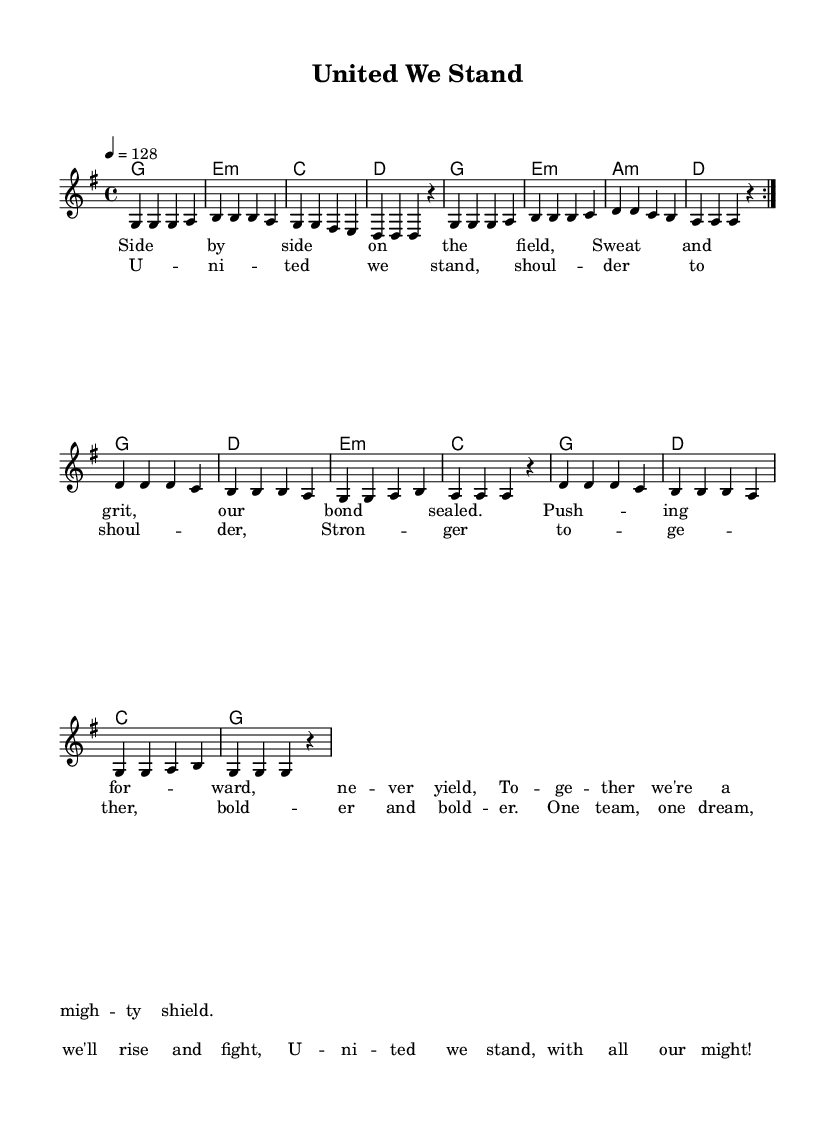What is the key signature of this music? The key signature is G major, which has one sharp (F#). This can be identified in the music sheet where it indicates the G major key.
Answer: G major What is the time signature of this music? The time signature is 4/4, which is indicated at the beginning of the music. This shows that there are four beats in a measure.
Answer: 4/4 What is the tempo marking of this piece? The tempo marking is 128 beats per minute, denoted as "4 = 128" in the header section of the music.
Answer: 128 How many measures are there in the melody? By counting the measures in the melody section, there are 16 measures in total, which consist of repetitions and breaks.
Answer: 16 What is the first lyric of the chorus? The first lyric is "United we stand," clearly specified in the chorus section of the lyrics.
Answer: United we stand Which chord follows the first melody note of the chorus? The first melody note of the chorus is "U", and it is accompanied by a G major chord as indicated in the harmonies.
Answer: G What theme does this song primarily express? The song expresses themes of teamwork and camaraderie, as evident from the lyrics that emphasize unity and strength together as a team.
Answer: Teamwork 